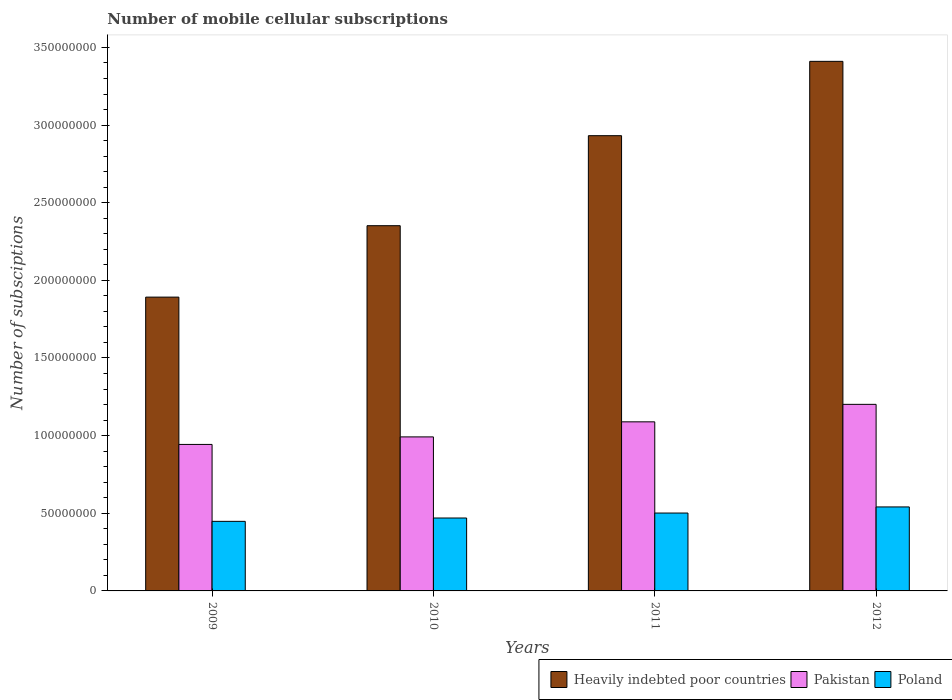How many different coloured bars are there?
Give a very brief answer. 3. How many groups of bars are there?
Offer a terse response. 4. Are the number of bars per tick equal to the number of legend labels?
Your response must be concise. Yes. Are the number of bars on each tick of the X-axis equal?
Ensure brevity in your answer.  Yes. How many bars are there on the 1st tick from the right?
Make the answer very short. 3. What is the number of mobile cellular subscriptions in Heavily indebted poor countries in 2009?
Make the answer very short. 1.89e+08. Across all years, what is the maximum number of mobile cellular subscriptions in Heavily indebted poor countries?
Your answer should be very brief. 3.41e+08. Across all years, what is the minimum number of mobile cellular subscriptions in Pakistan?
Give a very brief answer. 9.43e+07. What is the total number of mobile cellular subscriptions in Pakistan in the graph?
Offer a terse response. 4.23e+08. What is the difference between the number of mobile cellular subscriptions in Pakistan in 2011 and that in 2012?
Ensure brevity in your answer.  -1.13e+07. What is the difference between the number of mobile cellular subscriptions in Pakistan in 2011 and the number of mobile cellular subscriptions in Poland in 2009?
Your response must be concise. 6.41e+07. What is the average number of mobile cellular subscriptions in Poland per year?
Your response must be concise. 4.90e+07. In the year 2012, what is the difference between the number of mobile cellular subscriptions in Poland and number of mobile cellular subscriptions in Heavily indebted poor countries?
Ensure brevity in your answer.  -2.87e+08. What is the ratio of the number of mobile cellular subscriptions in Poland in 2011 to that in 2012?
Your response must be concise. 0.93. Is the number of mobile cellular subscriptions in Heavily indebted poor countries in 2009 less than that in 2011?
Provide a short and direct response. Yes. What is the difference between the highest and the second highest number of mobile cellular subscriptions in Poland?
Provide a succinct answer. 3.93e+06. What is the difference between the highest and the lowest number of mobile cellular subscriptions in Pakistan?
Provide a succinct answer. 2.58e+07. In how many years, is the number of mobile cellular subscriptions in Poland greater than the average number of mobile cellular subscriptions in Poland taken over all years?
Your answer should be compact. 2. Is the sum of the number of mobile cellular subscriptions in Pakistan in 2009 and 2010 greater than the maximum number of mobile cellular subscriptions in Poland across all years?
Your answer should be very brief. Yes. What does the 3rd bar from the right in 2011 represents?
Provide a succinct answer. Heavily indebted poor countries. Is it the case that in every year, the sum of the number of mobile cellular subscriptions in Pakistan and number of mobile cellular subscriptions in Heavily indebted poor countries is greater than the number of mobile cellular subscriptions in Poland?
Provide a short and direct response. Yes. Are all the bars in the graph horizontal?
Make the answer very short. No. What is the difference between two consecutive major ticks on the Y-axis?
Your answer should be very brief. 5.00e+07. Are the values on the major ticks of Y-axis written in scientific E-notation?
Ensure brevity in your answer.  No. Does the graph contain grids?
Offer a very short reply. No. What is the title of the graph?
Offer a very short reply. Number of mobile cellular subscriptions. Does "Samoa" appear as one of the legend labels in the graph?
Keep it short and to the point. No. What is the label or title of the Y-axis?
Offer a terse response. Number of subsciptions. What is the Number of subsciptions of Heavily indebted poor countries in 2009?
Make the answer very short. 1.89e+08. What is the Number of subsciptions in Pakistan in 2009?
Offer a terse response. 9.43e+07. What is the Number of subsciptions of Poland in 2009?
Provide a succinct answer. 4.48e+07. What is the Number of subsciptions of Heavily indebted poor countries in 2010?
Ensure brevity in your answer.  2.35e+08. What is the Number of subsciptions of Pakistan in 2010?
Provide a succinct answer. 9.92e+07. What is the Number of subsciptions of Poland in 2010?
Keep it short and to the point. 4.70e+07. What is the Number of subsciptions in Heavily indebted poor countries in 2011?
Provide a short and direct response. 2.93e+08. What is the Number of subsciptions in Pakistan in 2011?
Your response must be concise. 1.09e+08. What is the Number of subsciptions of Poland in 2011?
Your answer should be very brief. 5.02e+07. What is the Number of subsciptions of Heavily indebted poor countries in 2012?
Keep it short and to the point. 3.41e+08. What is the Number of subsciptions of Pakistan in 2012?
Your answer should be compact. 1.20e+08. What is the Number of subsciptions of Poland in 2012?
Your answer should be very brief. 5.41e+07. Across all years, what is the maximum Number of subsciptions of Heavily indebted poor countries?
Make the answer very short. 3.41e+08. Across all years, what is the maximum Number of subsciptions in Pakistan?
Provide a succinct answer. 1.20e+08. Across all years, what is the maximum Number of subsciptions in Poland?
Keep it short and to the point. 5.41e+07. Across all years, what is the minimum Number of subsciptions of Heavily indebted poor countries?
Provide a short and direct response. 1.89e+08. Across all years, what is the minimum Number of subsciptions in Pakistan?
Your response must be concise. 9.43e+07. Across all years, what is the minimum Number of subsciptions of Poland?
Provide a succinct answer. 4.48e+07. What is the total Number of subsciptions of Heavily indebted poor countries in the graph?
Give a very brief answer. 1.06e+09. What is the total Number of subsciptions in Pakistan in the graph?
Provide a short and direct response. 4.23e+08. What is the total Number of subsciptions in Poland in the graph?
Offer a very short reply. 1.96e+08. What is the difference between the Number of subsciptions of Heavily indebted poor countries in 2009 and that in 2010?
Give a very brief answer. -4.60e+07. What is the difference between the Number of subsciptions of Pakistan in 2009 and that in 2010?
Your response must be concise. -4.84e+06. What is the difference between the Number of subsciptions of Poland in 2009 and that in 2010?
Keep it short and to the point. -2.15e+06. What is the difference between the Number of subsciptions in Heavily indebted poor countries in 2009 and that in 2011?
Offer a very short reply. -1.04e+08. What is the difference between the Number of subsciptions in Pakistan in 2009 and that in 2011?
Ensure brevity in your answer.  -1.46e+07. What is the difference between the Number of subsciptions of Poland in 2009 and that in 2011?
Your response must be concise. -5.35e+06. What is the difference between the Number of subsciptions of Heavily indebted poor countries in 2009 and that in 2012?
Provide a succinct answer. -1.52e+08. What is the difference between the Number of subsciptions of Pakistan in 2009 and that in 2012?
Your response must be concise. -2.58e+07. What is the difference between the Number of subsciptions of Poland in 2009 and that in 2012?
Provide a succinct answer. -9.28e+06. What is the difference between the Number of subsciptions of Heavily indebted poor countries in 2010 and that in 2011?
Your answer should be very brief. -5.80e+07. What is the difference between the Number of subsciptions of Pakistan in 2010 and that in 2011?
Offer a very short reply. -9.71e+06. What is the difference between the Number of subsciptions of Poland in 2010 and that in 2011?
Offer a terse response. -3.21e+06. What is the difference between the Number of subsciptions in Heavily indebted poor countries in 2010 and that in 2012?
Your answer should be compact. -1.06e+08. What is the difference between the Number of subsciptions in Pakistan in 2010 and that in 2012?
Keep it short and to the point. -2.10e+07. What is the difference between the Number of subsciptions of Poland in 2010 and that in 2012?
Provide a short and direct response. -7.13e+06. What is the difference between the Number of subsciptions of Heavily indebted poor countries in 2011 and that in 2012?
Offer a terse response. -4.79e+07. What is the difference between the Number of subsciptions in Pakistan in 2011 and that in 2012?
Provide a short and direct response. -1.13e+07. What is the difference between the Number of subsciptions of Poland in 2011 and that in 2012?
Your answer should be very brief. -3.93e+06. What is the difference between the Number of subsciptions of Heavily indebted poor countries in 2009 and the Number of subsciptions of Pakistan in 2010?
Provide a succinct answer. 9.00e+07. What is the difference between the Number of subsciptions of Heavily indebted poor countries in 2009 and the Number of subsciptions of Poland in 2010?
Keep it short and to the point. 1.42e+08. What is the difference between the Number of subsciptions of Pakistan in 2009 and the Number of subsciptions of Poland in 2010?
Ensure brevity in your answer.  4.74e+07. What is the difference between the Number of subsciptions of Heavily indebted poor countries in 2009 and the Number of subsciptions of Pakistan in 2011?
Provide a short and direct response. 8.03e+07. What is the difference between the Number of subsciptions of Heavily indebted poor countries in 2009 and the Number of subsciptions of Poland in 2011?
Offer a terse response. 1.39e+08. What is the difference between the Number of subsciptions of Pakistan in 2009 and the Number of subsciptions of Poland in 2011?
Provide a succinct answer. 4.42e+07. What is the difference between the Number of subsciptions of Heavily indebted poor countries in 2009 and the Number of subsciptions of Pakistan in 2012?
Ensure brevity in your answer.  6.91e+07. What is the difference between the Number of subsciptions in Heavily indebted poor countries in 2009 and the Number of subsciptions in Poland in 2012?
Give a very brief answer. 1.35e+08. What is the difference between the Number of subsciptions of Pakistan in 2009 and the Number of subsciptions of Poland in 2012?
Your answer should be compact. 4.03e+07. What is the difference between the Number of subsciptions in Heavily indebted poor countries in 2010 and the Number of subsciptions in Pakistan in 2011?
Offer a very short reply. 1.26e+08. What is the difference between the Number of subsciptions of Heavily indebted poor countries in 2010 and the Number of subsciptions of Poland in 2011?
Your response must be concise. 1.85e+08. What is the difference between the Number of subsciptions of Pakistan in 2010 and the Number of subsciptions of Poland in 2011?
Ensure brevity in your answer.  4.90e+07. What is the difference between the Number of subsciptions of Heavily indebted poor countries in 2010 and the Number of subsciptions of Pakistan in 2012?
Ensure brevity in your answer.  1.15e+08. What is the difference between the Number of subsciptions in Heavily indebted poor countries in 2010 and the Number of subsciptions in Poland in 2012?
Provide a short and direct response. 1.81e+08. What is the difference between the Number of subsciptions in Pakistan in 2010 and the Number of subsciptions in Poland in 2012?
Provide a short and direct response. 4.51e+07. What is the difference between the Number of subsciptions of Heavily indebted poor countries in 2011 and the Number of subsciptions of Pakistan in 2012?
Make the answer very short. 1.73e+08. What is the difference between the Number of subsciptions in Heavily indebted poor countries in 2011 and the Number of subsciptions in Poland in 2012?
Keep it short and to the point. 2.39e+08. What is the difference between the Number of subsciptions of Pakistan in 2011 and the Number of subsciptions of Poland in 2012?
Keep it short and to the point. 5.48e+07. What is the average Number of subsciptions of Heavily indebted poor countries per year?
Your answer should be very brief. 2.65e+08. What is the average Number of subsciptions in Pakistan per year?
Make the answer very short. 1.06e+08. What is the average Number of subsciptions of Poland per year?
Give a very brief answer. 4.90e+07. In the year 2009, what is the difference between the Number of subsciptions of Heavily indebted poor countries and Number of subsciptions of Pakistan?
Your answer should be very brief. 9.49e+07. In the year 2009, what is the difference between the Number of subsciptions of Heavily indebted poor countries and Number of subsciptions of Poland?
Your answer should be very brief. 1.44e+08. In the year 2009, what is the difference between the Number of subsciptions in Pakistan and Number of subsciptions in Poland?
Ensure brevity in your answer.  4.95e+07. In the year 2010, what is the difference between the Number of subsciptions in Heavily indebted poor countries and Number of subsciptions in Pakistan?
Your answer should be compact. 1.36e+08. In the year 2010, what is the difference between the Number of subsciptions of Heavily indebted poor countries and Number of subsciptions of Poland?
Your answer should be very brief. 1.88e+08. In the year 2010, what is the difference between the Number of subsciptions of Pakistan and Number of subsciptions of Poland?
Your answer should be compact. 5.22e+07. In the year 2011, what is the difference between the Number of subsciptions of Heavily indebted poor countries and Number of subsciptions of Pakistan?
Your response must be concise. 1.84e+08. In the year 2011, what is the difference between the Number of subsciptions of Heavily indebted poor countries and Number of subsciptions of Poland?
Offer a terse response. 2.43e+08. In the year 2011, what is the difference between the Number of subsciptions of Pakistan and Number of subsciptions of Poland?
Your answer should be compact. 5.87e+07. In the year 2012, what is the difference between the Number of subsciptions in Heavily indebted poor countries and Number of subsciptions in Pakistan?
Your response must be concise. 2.21e+08. In the year 2012, what is the difference between the Number of subsciptions of Heavily indebted poor countries and Number of subsciptions of Poland?
Offer a very short reply. 2.87e+08. In the year 2012, what is the difference between the Number of subsciptions of Pakistan and Number of subsciptions of Poland?
Provide a short and direct response. 6.61e+07. What is the ratio of the Number of subsciptions of Heavily indebted poor countries in 2009 to that in 2010?
Your answer should be compact. 0.8. What is the ratio of the Number of subsciptions of Pakistan in 2009 to that in 2010?
Ensure brevity in your answer.  0.95. What is the ratio of the Number of subsciptions in Poland in 2009 to that in 2010?
Provide a succinct answer. 0.95. What is the ratio of the Number of subsciptions in Heavily indebted poor countries in 2009 to that in 2011?
Your answer should be compact. 0.65. What is the ratio of the Number of subsciptions of Pakistan in 2009 to that in 2011?
Offer a terse response. 0.87. What is the ratio of the Number of subsciptions of Poland in 2009 to that in 2011?
Your response must be concise. 0.89. What is the ratio of the Number of subsciptions in Heavily indebted poor countries in 2009 to that in 2012?
Give a very brief answer. 0.55. What is the ratio of the Number of subsciptions of Pakistan in 2009 to that in 2012?
Provide a short and direct response. 0.79. What is the ratio of the Number of subsciptions in Poland in 2009 to that in 2012?
Keep it short and to the point. 0.83. What is the ratio of the Number of subsciptions of Heavily indebted poor countries in 2010 to that in 2011?
Offer a very short reply. 0.8. What is the ratio of the Number of subsciptions in Pakistan in 2010 to that in 2011?
Provide a succinct answer. 0.91. What is the ratio of the Number of subsciptions in Poland in 2010 to that in 2011?
Offer a terse response. 0.94. What is the ratio of the Number of subsciptions of Heavily indebted poor countries in 2010 to that in 2012?
Your response must be concise. 0.69. What is the ratio of the Number of subsciptions in Pakistan in 2010 to that in 2012?
Ensure brevity in your answer.  0.83. What is the ratio of the Number of subsciptions of Poland in 2010 to that in 2012?
Provide a succinct answer. 0.87. What is the ratio of the Number of subsciptions of Heavily indebted poor countries in 2011 to that in 2012?
Your answer should be very brief. 0.86. What is the ratio of the Number of subsciptions in Pakistan in 2011 to that in 2012?
Make the answer very short. 0.91. What is the ratio of the Number of subsciptions in Poland in 2011 to that in 2012?
Provide a short and direct response. 0.93. What is the difference between the highest and the second highest Number of subsciptions of Heavily indebted poor countries?
Make the answer very short. 4.79e+07. What is the difference between the highest and the second highest Number of subsciptions of Pakistan?
Provide a succinct answer. 1.13e+07. What is the difference between the highest and the second highest Number of subsciptions in Poland?
Your answer should be compact. 3.93e+06. What is the difference between the highest and the lowest Number of subsciptions in Heavily indebted poor countries?
Offer a terse response. 1.52e+08. What is the difference between the highest and the lowest Number of subsciptions in Pakistan?
Offer a terse response. 2.58e+07. What is the difference between the highest and the lowest Number of subsciptions in Poland?
Offer a very short reply. 9.28e+06. 